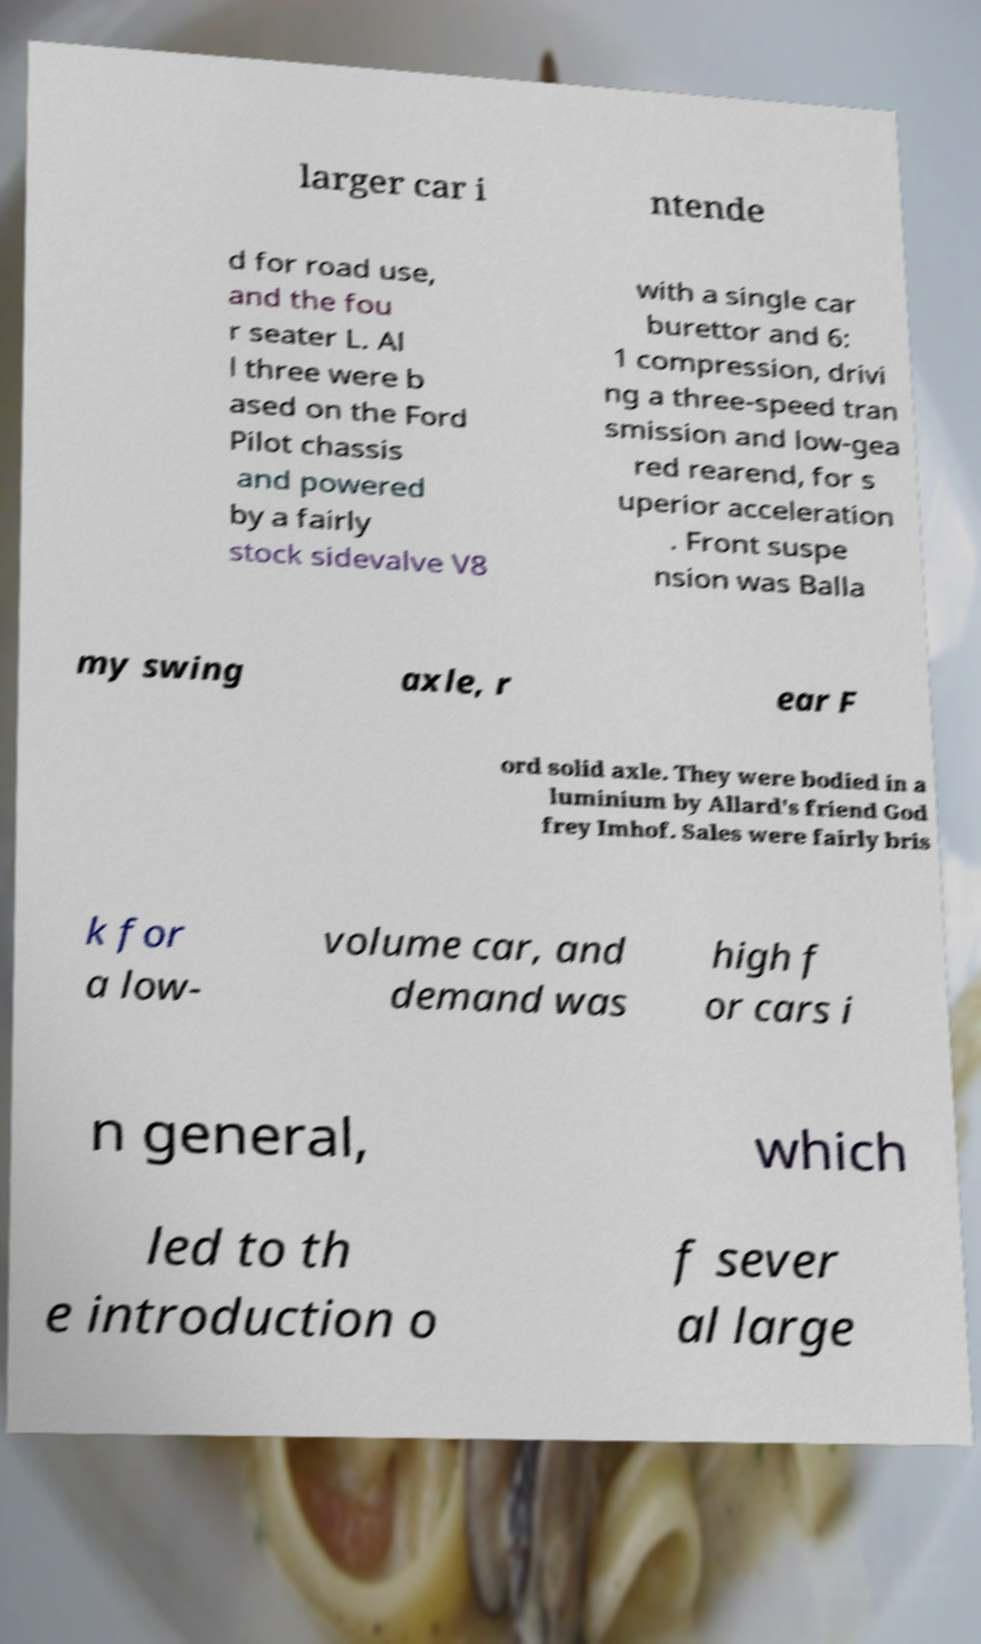Can you read and provide the text displayed in the image?This photo seems to have some interesting text. Can you extract and type it out for me? larger car i ntende d for road use, and the fou r seater L. Al l three were b ased on the Ford Pilot chassis and powered by a fairly stock sidevalve V8 with a single car burettor and 6: 1 compression, drivi ng a three-speed tran smission and low-gea red rearend, for s uperior acceleration . Front suspe nsion was Balla my swing axle, r ear F ord solid axle. They were bodied in a luminium by Allard's friend God frey Imhof. Sales were fairly bris k for a low- volume car, and demand was high f or cars i n general, which led to th e introduction o f sever al large 